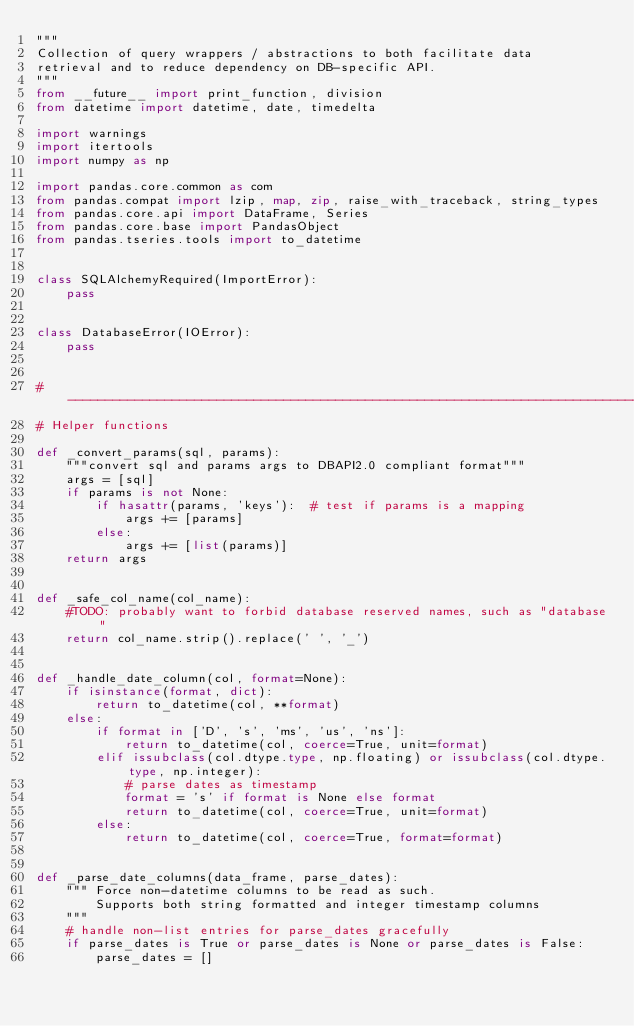<code> <loc_0><loc_0><loc_500><loc_500><_Python_>"""
Collection of query wrappers / abstractions to both facilitate data
retrieval and to reduce dependency on DB-specific API.
"""
from __future__ import print_function, division
from datetime import datetime, date, timedelta

import warnings
import itertools
import numpy as np

import pandas.core.common as com
from pandas.compat import lzip, map, zip, raise_with_traceback, string_types
from pandas.core.api import DataFrame, Series
from pandas.core.base import PandasObject
from pandas.tseries.tools import to_datetime


class SQLAlchemyRequired(ImportError):
    pass


class DatabaseError(IOError):
    pass


#------------------------------------------------------------------------------
# Helper functions

def _convert_params(sql, params):
    """convert sql and params args to DBAPI2.0 compliant format"""
    args = [sql]
    if params is not None:
        if hasattr(params, 'keys'):  # test if params is a mapping
            args += [params]
        else:
            args += [list(params)]
    return args


def _safe_col_name(col_name):
    #TODO: probably want to forbid database reserved names, such as "database"
    return col_name.strip().replace(' ', '_')


def _handle_date_column(col, format=None):
    if isinstance(format, dict):
        return to_datetime(col, **format)
    else:
        if format in ['D', 's', 'ms', 'us', 'ns']:
            return to_datetime(col, coerce=True, unit=format)
        elif issubclass(col.dtype.type, np.floating) or issubclass(col.dtype.type, np.integer):
            # parse dates as timestamp
            format = 's' if format is None else format
            return to_datetime(col, coerce=True, unit=format)
        else:
            return to_datetime(col, coerce=True, format=format)


def _parse_date_columns(data_frame, parse_dates):
    """ Force non-datetime columns to be read as such.
        Supports both string formatted and integer timestamp columns
    """
    # handle non-list entries for parse_dates gracefully
    if parse_dates is True or parse_dates is None or parse_dates is False:
        parse_dates = []
</code> 